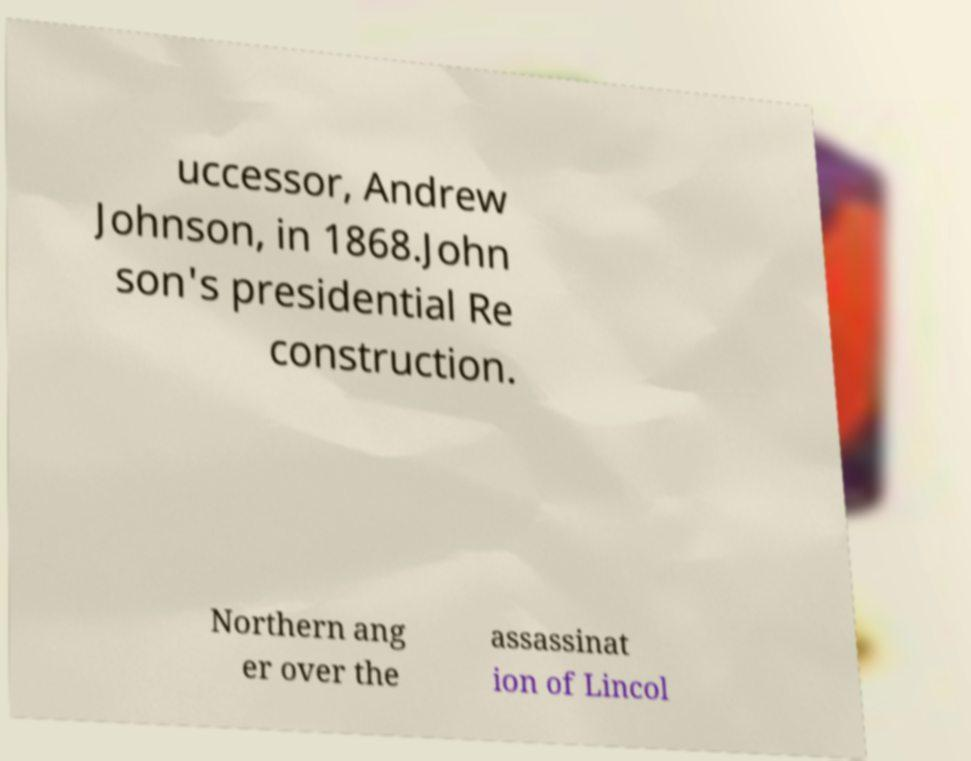Please read and relay the text visible in this image. What does it say? uccessor, Andrew Johnson, in 1868.John son's presidential Re construction. Northern ang er over the assassinat ion of Lincol 